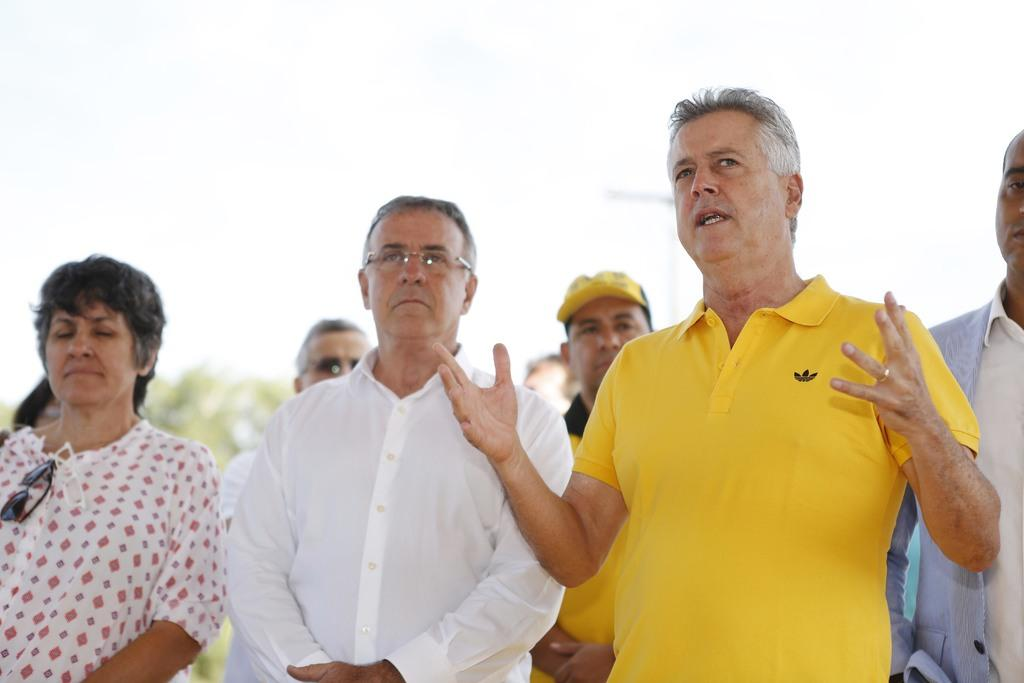What is happening in the image involving a group of people? There is a group of people standing in the image. Can you describe the activity of one person in the image? There is a person talking on the right side of the image. What can be seen in the background of the image? There are trees and the sky visible in the background of the image. How many bushes are present in the image? There are no bushes mentioned or visible in the image. Is this a family gathering, based on the people in the image? The provided facts do not indicate whether the group of people is a family or not, so we cannot definitively answer that question. 